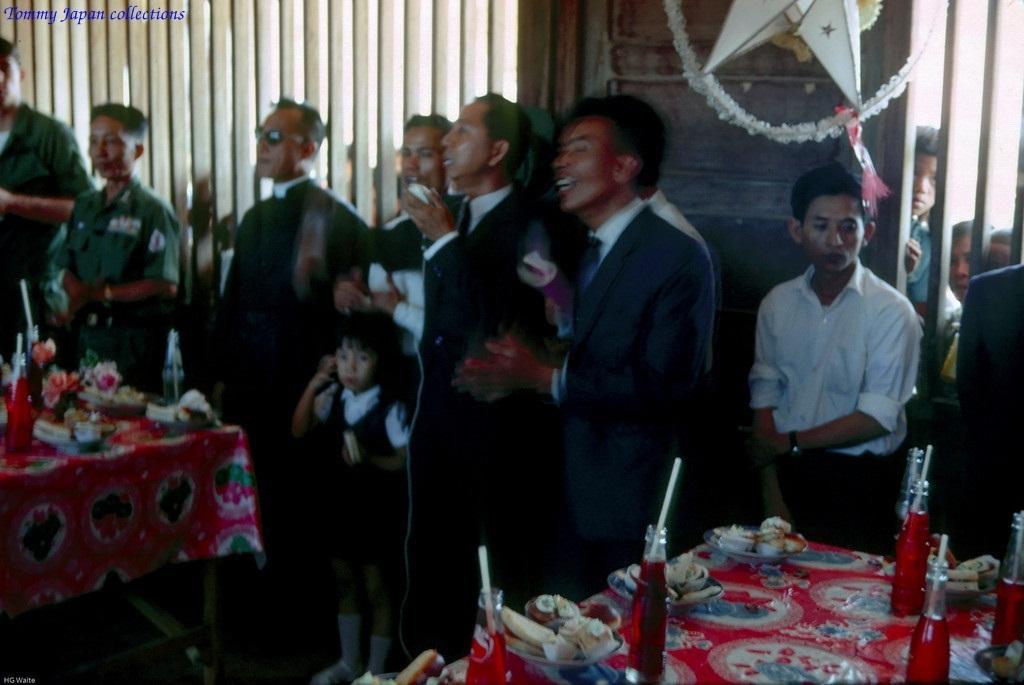Please provide a concise description of this image. In this image I can see the table and on the table I can see few bowls with food items in them and few bottles with liquid and straws in them. I can see number of persons are standing, the wall,a decorative item and another table with few items on it. 